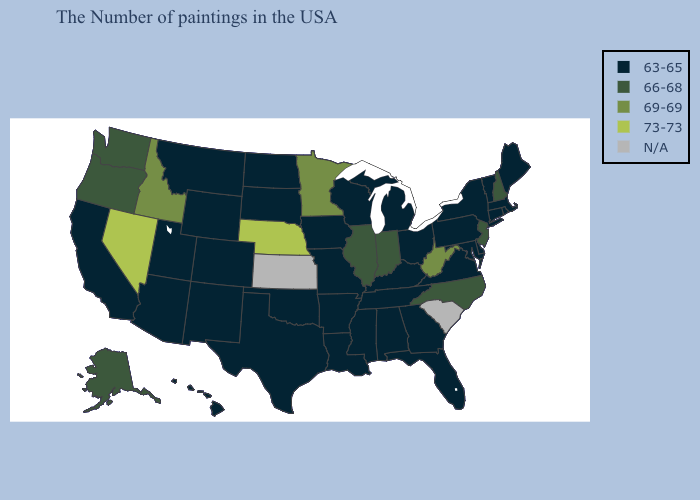What is the highest value in the USA?
Give a very brief answer. 73-73. Name the states that have a value in the range N/A?
Quick response, please. South Carolina, Kansas. Name the states that have a value in the range 66-68?
Answer briefly. New Hampshire, New Jersey, North Carolina, Indiana, Illinois, Washington, Oregon, Alaska. What is the value of Kentucky?
Give a very brief answer. 63-65. Does Virginia have the lowest value in the USA?
Short answer required. Yes. Among the states that border Kansas , which have the highest value?
Answer briefly. Nebraska. What is the value of New Hampshire?
Give a very brief answer. 66-68. How many symbols are there in the legend?
Give a very brief answer. 5. Which states have the lowest value in the MidWest?
Short answer required. Ohio, Michigan, Wisconsin, Missouri, Iowa, South Dakota, North Dakota. How many symbols are there in the legend?
Give a very brief answer. 5. Does New Hampshire have the highest value in the Northeast?
Keep it brief. Yes. Name the states that have a value in the range 63-65?
Keep it brief. Maine, Massachusetts, Rhode Island, Vermont, Connecticut, New York, Delaware, Maryland, Pennsylvania, Virginia, Ohio, Florida, Georgia, Michigan, Kentucky, Alabama, Tennessee, Wisconsin, Mississippi, Louisiana, Missouri, Arkansas, Iowa, Oklahoma, Texas, South Dakota, North Dakota, Wyoming, Colorado, New Mexico, Utah, Montana, Arizona, California, Hawaii. Name the states that have a value in the range N/A?
Write a very short answer. South Carolina, Kansas. What is the value of Texas?
Give a very brief answer. 63-65. What is the value of Kansas?
Be succinct. N/A. 